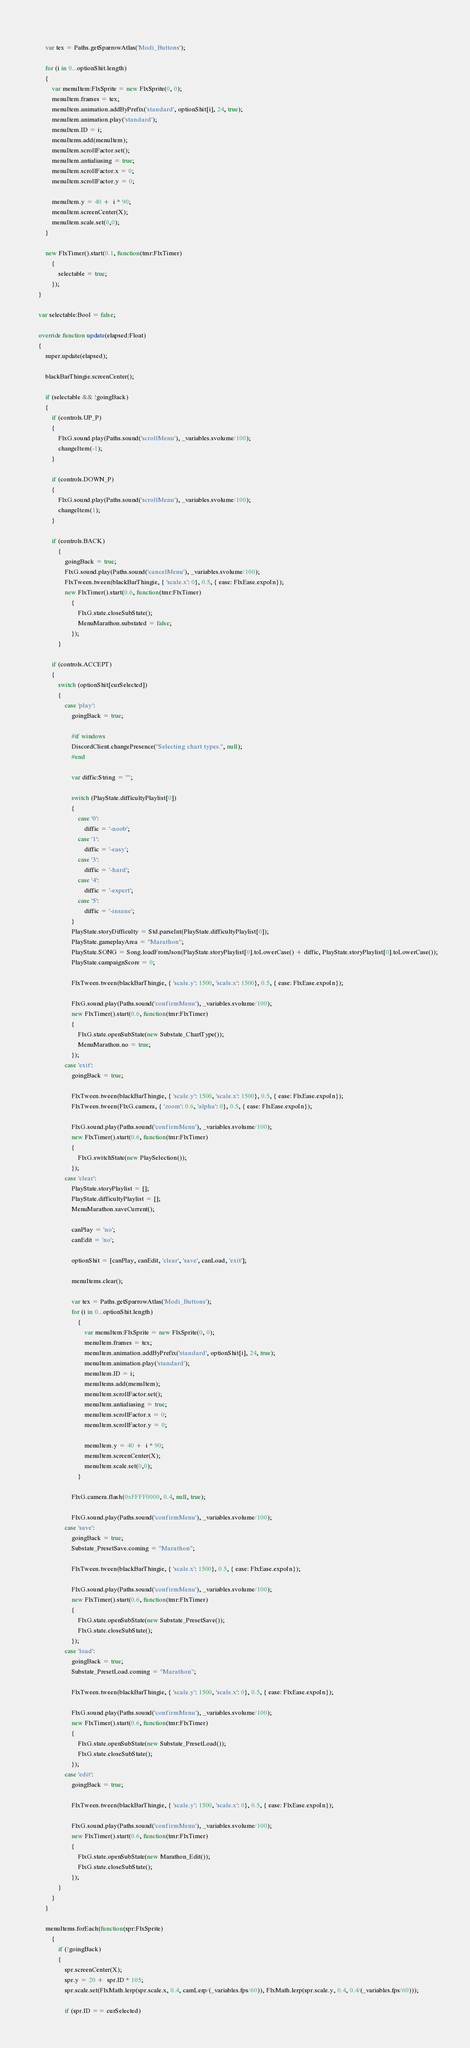Convert code to text. <code><loc_0><loc_0><loc_500><loc_500><_Haxe_>        
		var tex = Paths.getSparrowAtlas('Modi_Buttons');

		for (i in 0...optionShit.length)
		{
			var menuItem:FlxSprite = new FlxSprite(0, 0);
			menuItem.frames = tex;
            menuItem.animation.addByPrefix('standard', optionShit[i], 24, true);
			menuItem.animation.play('standard');
			menuItem.ID = i;
			menuItems.add(menuItem);
			menuItem.scrollFactor.set();
            menuItem.antialiasing = true;
            menuItem.scrollFactor.x = 0;
            menuItem.scrollFactor.y = 0;

            menuItem.y = 40 +  i * 90;
            menuItem.screenCenter(X);
            menuItem.scale.set(0,0);
        }

        new FlxTimer().start(0.1, function(tmr:FlxTimer)
			{
				selectable = true;
			});
    }

    var selectable:Bool = false;

    override function update(elapsed:Float)
    {
        super.update(elapsed);

        blackBarThingie.screenCenter();

        if (selectable && !goingBack)
        {
            if (controls.UP_P)
            {
                FlxG.sound.play(Paths.sound('scrollMenu'), _variables.svolume/100);
                changeItem(-1);
            }
    
            if (controls.DOWN_P)
            {
                FlxG.sound.play(Paths.sound('scrollMenu'), _variables.svolume/100);
                changeItem(1);
            }

            if (controls.BACK)
                {
                    goingBack = true;
                    FlxG.sound.play(Paths.sound('cancelMenu'), _variables.svolume/100);
                    FlxTween.tween(blackBarThingie, { 'scale.x': 0}, 0.5, { ease: FlxEase.expoIn});
                    new FlxTimer().start(0.6, function(tmr:FlxTimer)
                        {
                            FlxG.state.closeSubState();
                            MenuMarathon.substated = false;
                        });
                }
        
            if (controls.ACCEPT)
            {
                switch (optionShit[curSelected])
                {
                    case 'play':
                        goingBack = true;

                        #if windows
						DiscordClient.changePresence("Selecting chart types.", null);
				        #end

                        var diffic:String = "";

                        switch (PlayState.difficultyPlaylist[0])
			            {
			            	case '0':
			            		diffic = '-noob';
			            	case '1':
			            		diffic = '-easy';
			            	case '3':
			            		diffic = '-hard';
			            	case '4':
			            		diffic = '-expert';
			            	case '5':
			            		diffic = '-insane';
			            }
                        PlayState.storyDifficulty = Std.parseInt(PlayState.difficultyPlaylist[0]);
                        PlayState.gameplayArea = "Marathon";
			            PlayState.SONG = Song.loadFromJson(PlayState.storyPlaylist[0].toLowerCase() + diffic, PlayState.storyPlaylist[0].toLowerCase());
                        PlayState.campaignScore = 0;
                                
                        FlxTween.tween(blackBarThingie, { 'scale.y': 1500, 'scale.x': 1500}, 0.5, { ease: FlxEase.expoIn});
        
                        FlxG.sound.play(Paths.sound('confirmMenu'), _variables.svolume/100);
                        new FlxTimer().start(0.6, function(tmr:FlxTimer)
                        {
                            FlxG.state.openSubState(new Substate_ChartType());
                            MenuMarathon.no = true;
                        });
                    case 'exit':
                        goingBack = true;
                                
                        FlxTween.tween(blackBarThingie, { 'scale.y': 1500, 'scale.x': 1500}, 0.5, { ease: FlxEase.expoIn});
                        FlxTween.tween(FlxG.camera, { 'zoom': 0.6, 'alpha': 0}, 0.5, { ease: FlxEase.expoIn});
        
                        FlxG.sound.play(Paths.sound('confirmMenu'), _variables.svolume/100);
                        new FlxTimer().start(0.6, function(tmr:FlxTimer)
                        {
                            FlxG.switchState(new PlaySelection());
                        });
                    case 'clear':
                        PlayState.storyPlaylist = [];
                        PlayState.difficultyPlaylist = [];
                        MenuMarathon.saveCurrent();

                        canPlay = 'no';
                        canEdit = 'no';

                        optionShit = [canPlay, canEdit, 'clear', 'save', canLoad, 'exit'];

                        menuItems.clear();

                        var tex = Paths.getSparrowAtlas('Modi_Buttons');
                        for (i in 0...optionShit.length)
                            {
                                var menuItem:FlxSprite = new FlxSprite(0, 0);
                                menuItem.frames = tex;
                                menuItem.animation.addByPrefix('standard', optionShit[i], 24, true);
                                menuItem.animation.play('standard');
                                menuItem.ID = i;
                                menuItems.add(menuItem);
                                menuItem.scrollFactor.set();
                                menuItem.antialiasing = true;
                                menuItem.scrollFactor.x = 0;
                                menuItem.scrollFactor.y = 0;
                    
                                menuItem.y = 40 +  i * 90;
                                menuItem.screenCenter(X);
                                menuItem.scale.set(0,0);
                            }

                        FlxG.camera.flash(0xFFFF0000, 0.4, null, true);

                        FlxG.sound.play(Paths.sound('confirmMenu'), _variables.svolume/100);
                    case 'save':
                        goingBack = true;
                        Substate_PresetSave.coming = "Marathon";
                            
                        FlxTween.tween(blackBarThingie, { 'scale.x': 1500}, 0.5, { ease: FlxEase.expoIn});
    
                        FlxG.sound.play(Paths.sound('confirmMenu'), _variables.svolume/100);
                        new FlxTimer().start(0.6, function(tmr:FlxTimer)
                        {
                            FlxG.state.openSubState(new Substate_PresetSave());
                            FlxG.state.closeSubState();
                        });
                    case 'load':
                        goingBack = true;
                        Substate_PresetLoad.coming = "Marathon";
                                
                        FlxTween.tween(blackBarThingie, { 'scale.y': 1500, 'scale.x': 0}, 0.5, { ease: FlxEase.expoIn});
        
                        FlxG.sound.play(Paths.sound('confirmMenu'), _variables.svolume/100);
                        new FlxTimer().start(0.6, function(tmr:FlxTimer)
                        {
                            FlxG.state.openSubState(new Substate_PresetLoad());
                            FlxG.state.closeSubState();
                        });
                    case 'edit':
                        goingBack = true;
                                    
                        FlxTween.tween(blackBarThingie, { 'scale.y': 1500, 'scale.x': 0}, 0.5, { ease: FlxEase.expoIn});
            
                        FlxG.sound.play(Paths.sound('confirmMenu'), _variables.svolume/100);
                        new FlxTimer().start(0.6, function(tmr:FlxTimer)
                        {
                            FlxG.state.openSubState(new Marathon_Edit());
                            FlxG.state.closeSubState();
                        });
                }
            }
        }

        menuItems.forEach(function(spr:FlxSprite)
            {
                if (!goingBack)
                {
                    spr.screenCenter(X);
                    spr.y = 20 +  spr.ID * 105;
                    spr.scale.set(FlxMath.lerp(spr.scale.x, 0.4, camLerp/(_variables.fps/60)), FlxMath.lerp(spr.scale.y, 0.4, 0.4/(_variables.fps/60)));
    
                    if (spr.ID == curSelected)</code> 